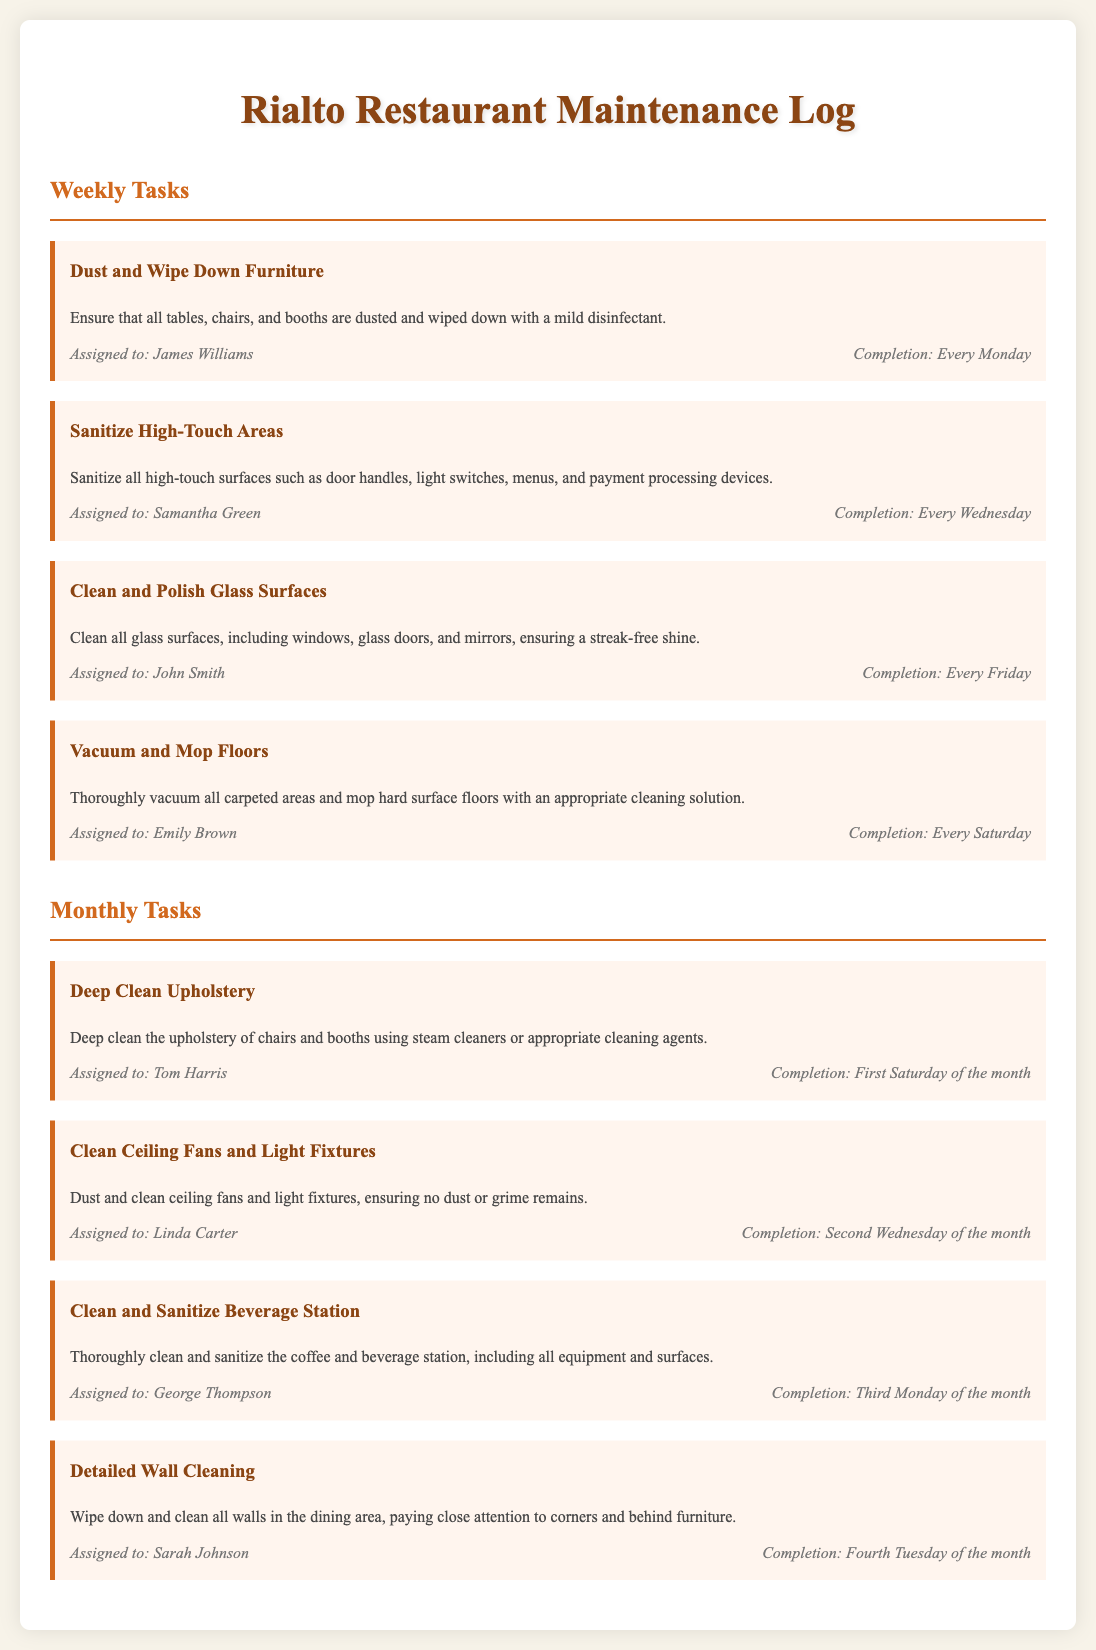What are the weekly tasks? Weekly tasks include dusting furniture, sanitizing high-touch areas, cleaning glass surfaces, and vacuuming/mopping floors.
Answer: Dust and Wipe Down Furniture, Sanitize High-Touch Areas, Clean and Polish Glass Surfaces, Vacuum and Mop Floors Who is assigned to clean the beverage station? The document specifies that George Thompson is responsible for cleaning and sanitizing the beverage station.
Answer: George Thompson When is the detailed wall cleaning scheduled? According to the document, the detailed wall cleaning is scheduled for the fourth Tuesday of the month.
Answer: Fourth Tuesday of the month How often is upholstery deep cleaned? The maintenance log indicates that upholstery is deep cleaned once a month, specifically on the first Saturday.
Answer: Once a month What type of cleaning is done on the second Wednesday of the month? The second Wednesday of the month involves cleaning ceiling fans and light fixtures.
Answer: Clean Ceiling Fans and Light Fixtures What is the main focus of the task assigned to Emily Brown? Emily Brown is responsible for vacuuming and mopping floors, as mentioned in her task description.
Answer: Vacuum and Mop Floors Which task requires steam cleaning? The deep clean upholstery task requires the use of steam cleaners or appropriate cleaning agents.
Answer: Deep Clean Upholstery On which day are high-touch surfaces sanitized? High-touch surfaces are sanitized every Wednesday, as stated in the document.
Answer: Every Wednesday Who performs the task of cleaning glass surfaces? John Smith is assigned to clean and polish glass surfaces every Friday.
Answer: John Smith 